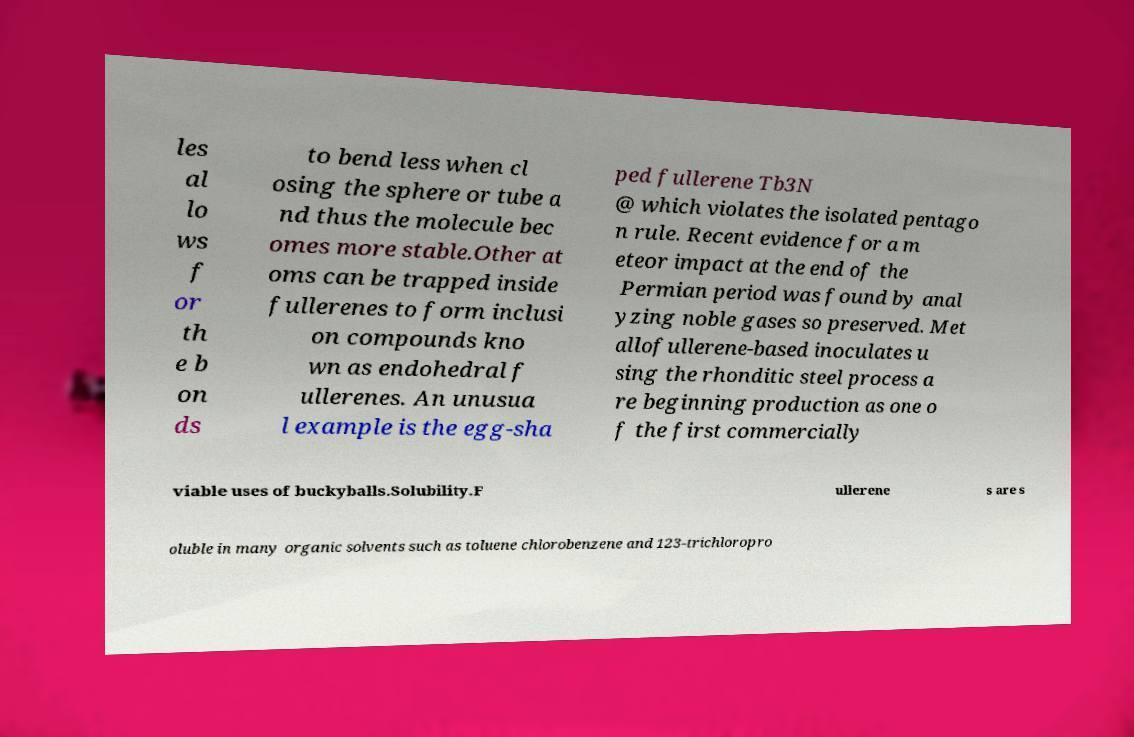There's text embedded in this image that I need extracted. Can you transcribe it verbatim? les al lo ws f or th e b on ds to bend less when cl osing the sphere or tube a nd thus the molecule bec omes more stable.Other at oms can be trapped inside fullerenes to form inclusi on compounds kno wn as endohedral f ullerenes. An unusua l example is the egg-sha ped fullerene Tb3N @ which violates the isolated pentago n rule. Recent evidence for a m eteor impact at the end of the Permian period was found by anal yzing noble gases so preserved. Met allofullerene-based inoculates u sing the rhonditic steel process a re beginning production as one o f the first commercially viable uses of buckyballs.Solubility.F ullerene s are s oluble in many organic solvents such as toluene chlorobenzene and 123-trichloropro 